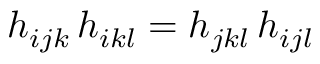Convert formula to latex. <formula><loc_0><loc_0><loc_500><loc_500>h _ { i j k } \, h _ { i k l } = h _ { j k l } \, h _ { i j l }</formula> 